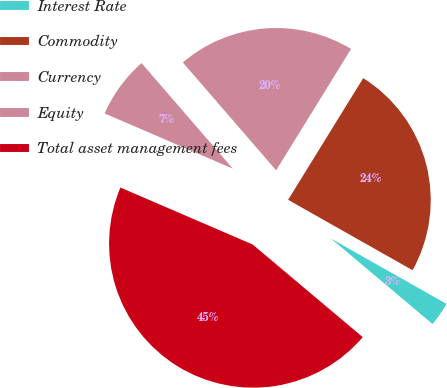Convert chart. <chart><loc_0><loc_0><loc_500><loc_500><pie_chart><fcel>Interest Rate<fcel>Commodity<fcel>Currency<fcel>Equity<fcel>Total asset management fees<nl><fcel>2.94%<fcel>24.39%<fcel>20.15%<fcel>7.18%<fcel>45.34%<nl></chart> 